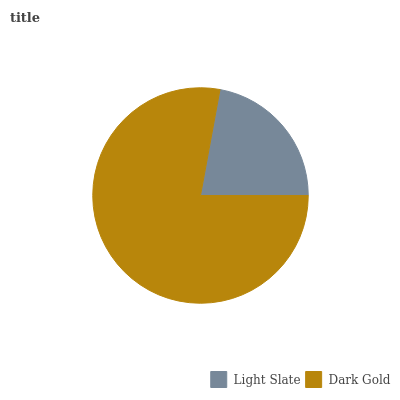Is Light Slate the minimum?
Answer yes or no. Yes. Is Dark Gold the maximum?
Answer yes or no. Yes. Is Dark Gold the minimum?
Answer yes or no. No. Is Dark Gold greater than Light Slate?
Answer yes or no. Yes. Is Light Slate less than Dark Gold?
Answer yes or no. Yes. Is Light Slate greater than Dark Gold?
Answer yes or no. No. Is Dark Gold less than Light Slate?
Answer yes or no. No. Is Dark Gold the high median?
Answer yes or no. Yes. Is Light Slate the low median?
Answer yes or no. Yes. Is Light Slate the high median?
Answer yes or no. No. Is Dark Gold the low median?
Answer yes or no. No. 